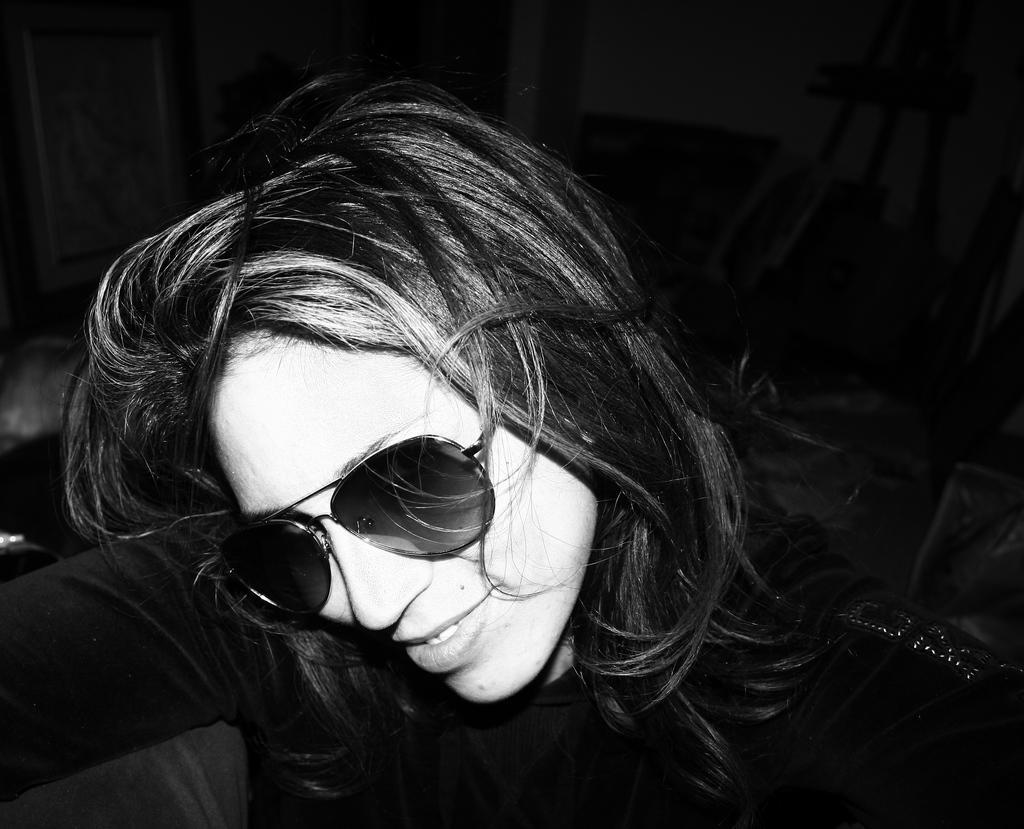How would you summarize this image in a sentence or two? This is a black and white image. In this image we can see a woman wearing spectacles. 